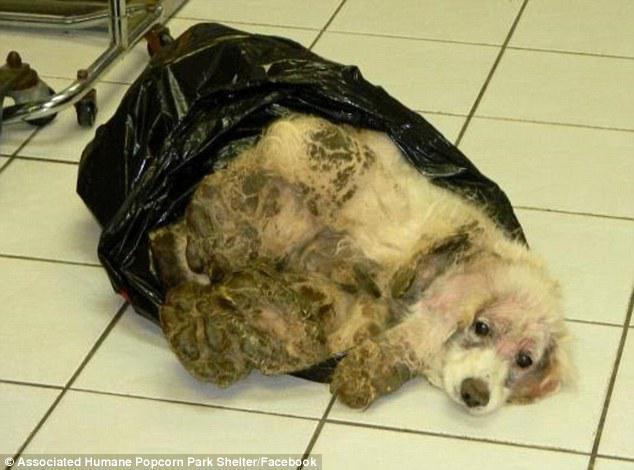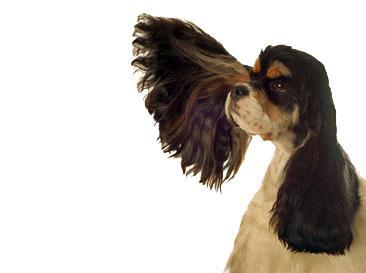The first image is the image on the left, the second image is the image on the right. Examine the images to the left and right. Is the description "Human hands can be seen holding the dog's ear in one image." accurate? Answer yes or no. No. 